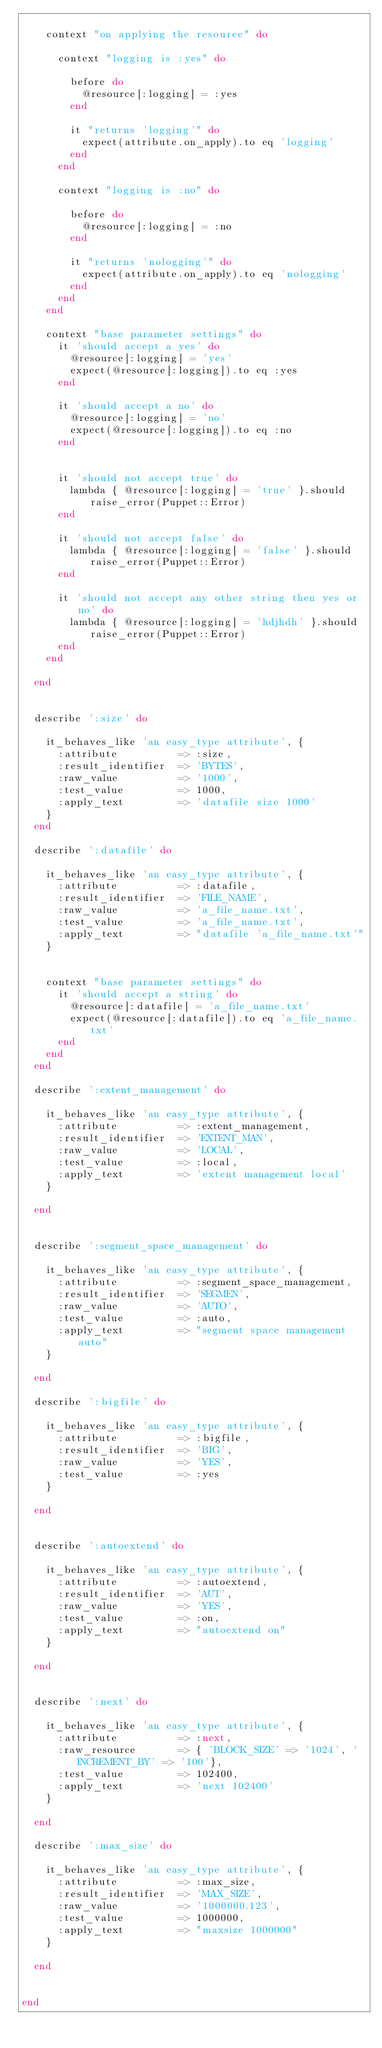<code> <loc_0><loc_0><loc_500><loc_500><_Ruby_>
    context "on applying the resource" do

      context "logging is :yes" do

        before do
          @resource[:logging] = :yes
        end

        it "returns 'logging'" do
          expect(attribute.on_apply).to eq 'logging'
        end
      end

      context "logging is :no" do

        before do
          @resource[:logging] = :no
        end

        it "returns 'nologging'" do
          expect(attribute.on_apply).to eq 'nologging'
        end
      end
    end

    context "base parameter settings" do
      it 'should accept a yes' do
        @resource[:logging] = 'yes'
        expect(@resource[:logging]).to eq :yes
      end

      it 'should accept a no' do
        @resource[:logging] = 'no'
        expect(@resource[:logging]).to eq :no
      end


      it 'should not accept true' do
        lambda { @resource[:logging] = 'true' }.should raise_error(Puppet::Error)
      end

      it 'should not accept false' do
        lambda { @resource[:logging] = 'false' }.should raise_error(Puppet::Error)
      end

      it 'should not accept any other string then yes or no' do
        lambda { @resource[:logging] = 'hdjhdh' }.should raise_error(Puppet::Error)
      end
    end

  end


  describe ':size' do

    it_behaves_like 'an easy_type attribute', {
      :attribute          => :size,
      :result_identifier  => 'BYTES',
      :raw_value          => '1000',
      :test_value         => 1000,
      :apply_text         => 'datafile size 1000'
    }
  end

  describe ':datafile' do

    it_behaves_like 'an easy_type attribute', {
      :attribute          => :datafile,
      :result_identifier  => 'FILE_NAME',
      :raw_value          => 'a_file_name.txt',
      :test_value         => 'a_file_name.txt',
      :apply_text         => "datafile 'a_file_name.txt'"
    }


    context "base parameter settings" do
      it 'should accept a string' do
        @resource[:datafile] = 'a_file_name.txt'
        expect(@resource[:datafile]).to eq 'a_file_name.txt'
      end
    end
  end

  describe ':extent_management' do

    it_behaves_like 'an easy_type attribute', {
      :attribute          => :extent_management,
      :result_identifier  => 'EXTENT_MAN',
      :raw_value          => 'LOCAL',
      :test_value         => :local,
      :apply_text         => 'extent management local'
    }

  end


  describe ':segment_space_management' do

    it_behaves_like 'an easy_type attribute', {
      :attribute          => :segment_space_management,
      :result_identifier  => 'SEGMEN',
      :raw_value          => 'AUTO',
      :test_value         => :auto,
      :apply_text         => "segment space management auto"
    }

  end

  describe ':bigfile' do

    it_behaves_like 'an easy_type attribute', {
      :attribute          => :bigfile,
      :result_identifier  => 'BIG',
      :raw_value          => 'YES',
      :test_value         => :yes
    }

  end


  describe ':autoextend' do

    it_behaves_like 'an easy_type attribute', {
      :attribute          => :autoextend,
      :result_identifier  => 'AUT',
      :raw_value          => 'YES',
      :test_value         => :on,
      :apply_text         => "autoextend on"
    }

  end


  describe ':next' do

    it_behaves_like 'an easy_type attribute', {
      :attribute          => :next,
      :raw_resource       => { 'BLOCK_SIZE' => '1024', 'INCREMENT_BY' => '100'},
      :test_value         => 102400,
      :apply_text         => 'next 102400'
    }

  end

  describe ':max_size' do

    it_behaves_like 'an easy_type attribute', {
      :attribute          => :max_size,
      :result_identifier  => 'MAX_SIZE',
      :raw_value          => '1000000.123',
      :test_value         => 1000000,
      :apply_text         => "maxsize 1000000"
    }

  end


end</code> 